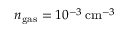Convert formula to latex. <formula><loc_0><loc_0><loc_500><loc_500>{ n _ { g a s } = 1 0 ^ { - 3 } \, c m ^ { - 3 } }</formula> 